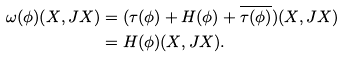Convert formula to latex. <formula><loc_0><loc_0><loc_500><loc_500>\omega ( \phi ) ( X , J X ) & = ( \tau ( \phi ) + H ( \phi ) + \overline { \tau ( \phi ) } ) ( X , J X ) \\ & = H ( \phi ) ( X , J X ) .</formula> 